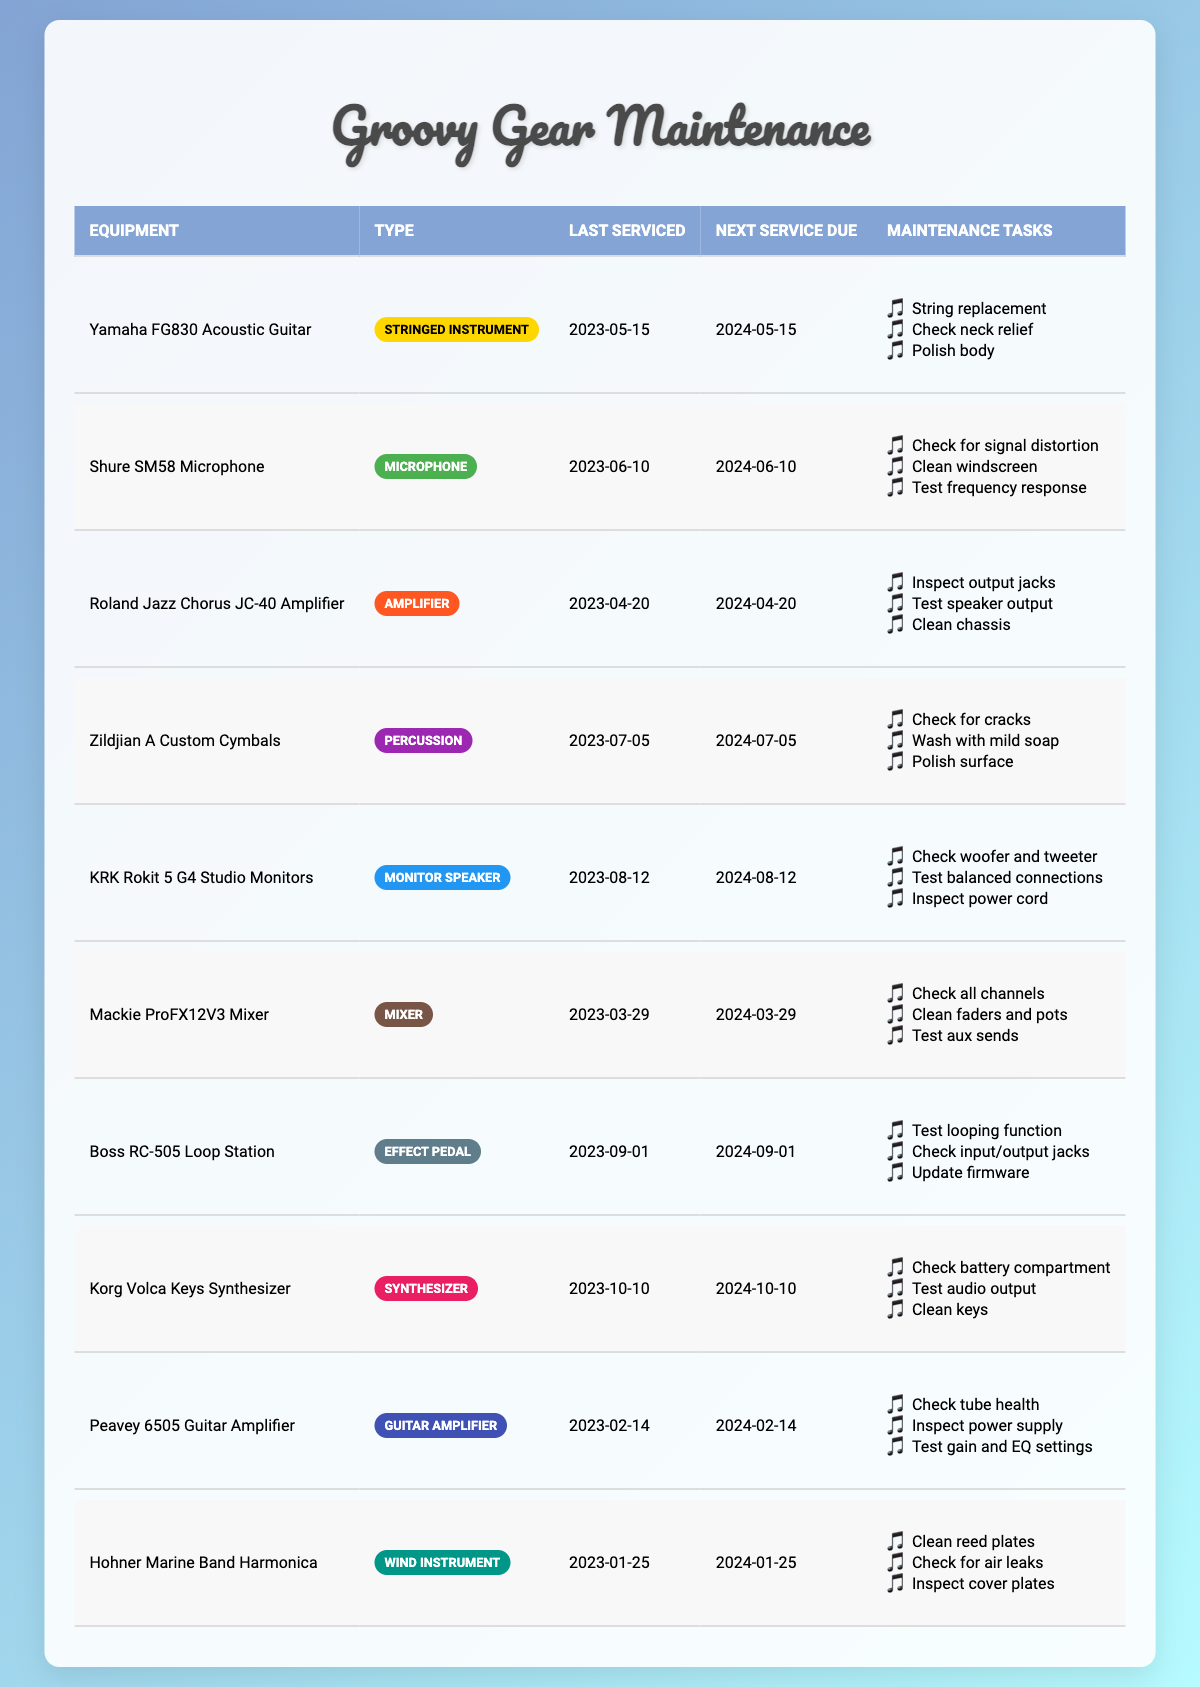What is the next service due date for the Yamaha FG830 Acoustic Guitar? According to the table, the next service due date for the Yamaha FG830 Acoustic Guitar is listed as 2024-05-15.
Answer: 2024-05-15 When was the last service for the Shure SM58 Microphone? The last service date for the Shure SM58 Microphone is mentioned in the table as 2023-06-10.
Answer: 2023-06-10 How many equipment items have a next service due date in 2024? By counting the next service due dates of all items, there are 8 items set for service in 2024. These items are listed with their next service due dates: Yamaha FG830 (2024-05-15), Shure SM58 (2024-06-10), Roland Jazz Chorus JC-40 (2024-04-20), Zildjian A Custom (2024-07-05), KRK Rokit 5 (2024-08-12), Mackie ProFX12V3 (2024-03-29), Boss RC-505 (2024-09-01), Korg Volca Keys (2024-10-10), Peavey 6505 (2024-02-14), Hohner Marine Band (2024-01-25). Total count = 10.
Answer: 10 Is the maintenance task “Test frequency response” required for the Shure SM58 Microphone? Yes, this maintenance task is explicitly listed in the table under the maintenance tasks for the Shure SM58 Microphone.
Answer: Yes Which equipment type requires the task “Inspect power supply”? The Peavey 6505 Guitar Amplifier has the maintenance task “Inspect power supply” listed under its maintenance schedule in the table.
Answer: Guitar amplifier What are the maintenance tasks for the KRK Rokit 5 G4 Studio Monitors? The maintenance tasks listed for the KRK Rokit 5 G4 Studio Monitors are: Check woofer and tweeter, Test balanced connections, Inspect power cord. These can be directly seen under its row in the table.
Answer: Check woofer and tweeter; Test balanced connections; Inspect power cord Which piece of equipment was last serviced on 2023-01-25 and when is its next service due? The Hohner Marine Band Harmonica was last serviced on 2023-01-25, and its next service is due on 2024-01-25, as indicated in the table.
Answer: 2024-01-25 How many equipment types listed in the table are stringed instruments? There is one piece of equipment in the table that is a stringed instrument, which is the Yamaha FG830 Acoustic Guitar.
Answer: 1 